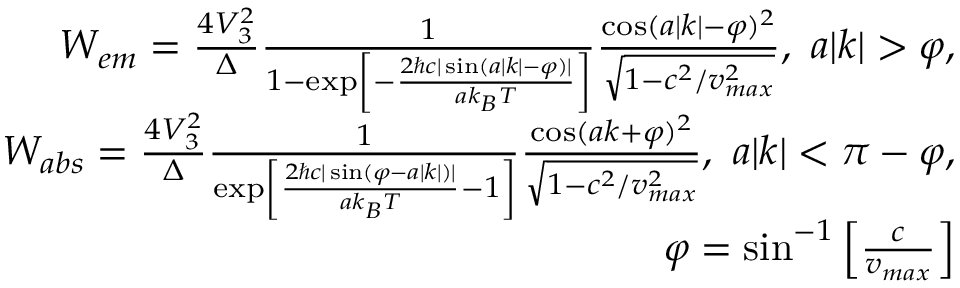Convert formula to latex. <formula><loc_0><loc_0><loc_500><loc_500>\begin{array} { r } { W _ { e m } = \frac { 4 V _ { 3 } ^ { 2 } } { \Delta } \frac { 1 } { 1 - \exp \left [ - \frac { 2 \hbar { c } | \sin ( a | k | - \varphi ) | } { a k _ { B } T } \right ] } \frac { \cos ( a | k | - \varphi ) ^ { 2 } } { \sqrt { 1 - c ^ { 2 } / v _ { \max } ^ { 2 } } } , a | k | > \varphi , } \\ { W _ { a b s } = \frac { 4 V _ { 3 } ^ { 2 } } { \Delta } \frac { 1 } { \exp \left [ \frac { 2 \hbar { c } | \sin ( \varphi - a | k | ) | } { a k _ { B } T } - 1 \right ] } \frac { \cos ( a k + \varphi ) ^ { 2 } } { \sqrt { 1 - c ^ { 2 } / v _ { \max } ^ { 2 } } } , a | k | < \pi - \varphi , } \\ { \varphi = \sin ^ { - 1 } \left [ \frac { c } { v _ { \max } } \right ] } \end{array}</formula> 